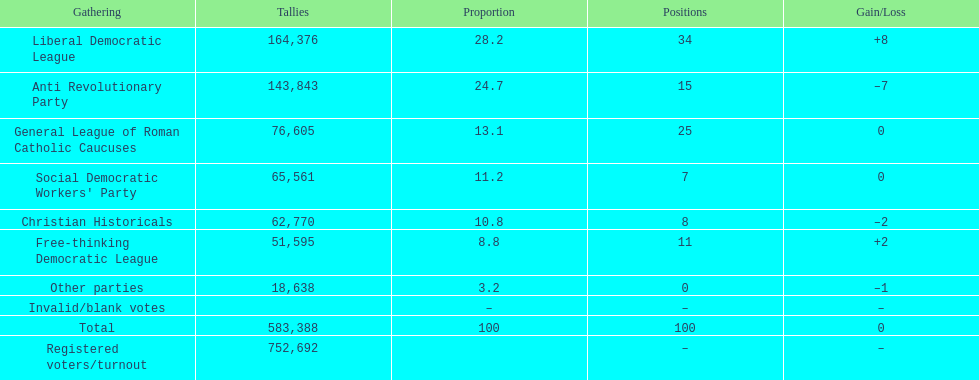How many votes were counted as invalid or blank votes? 0. 